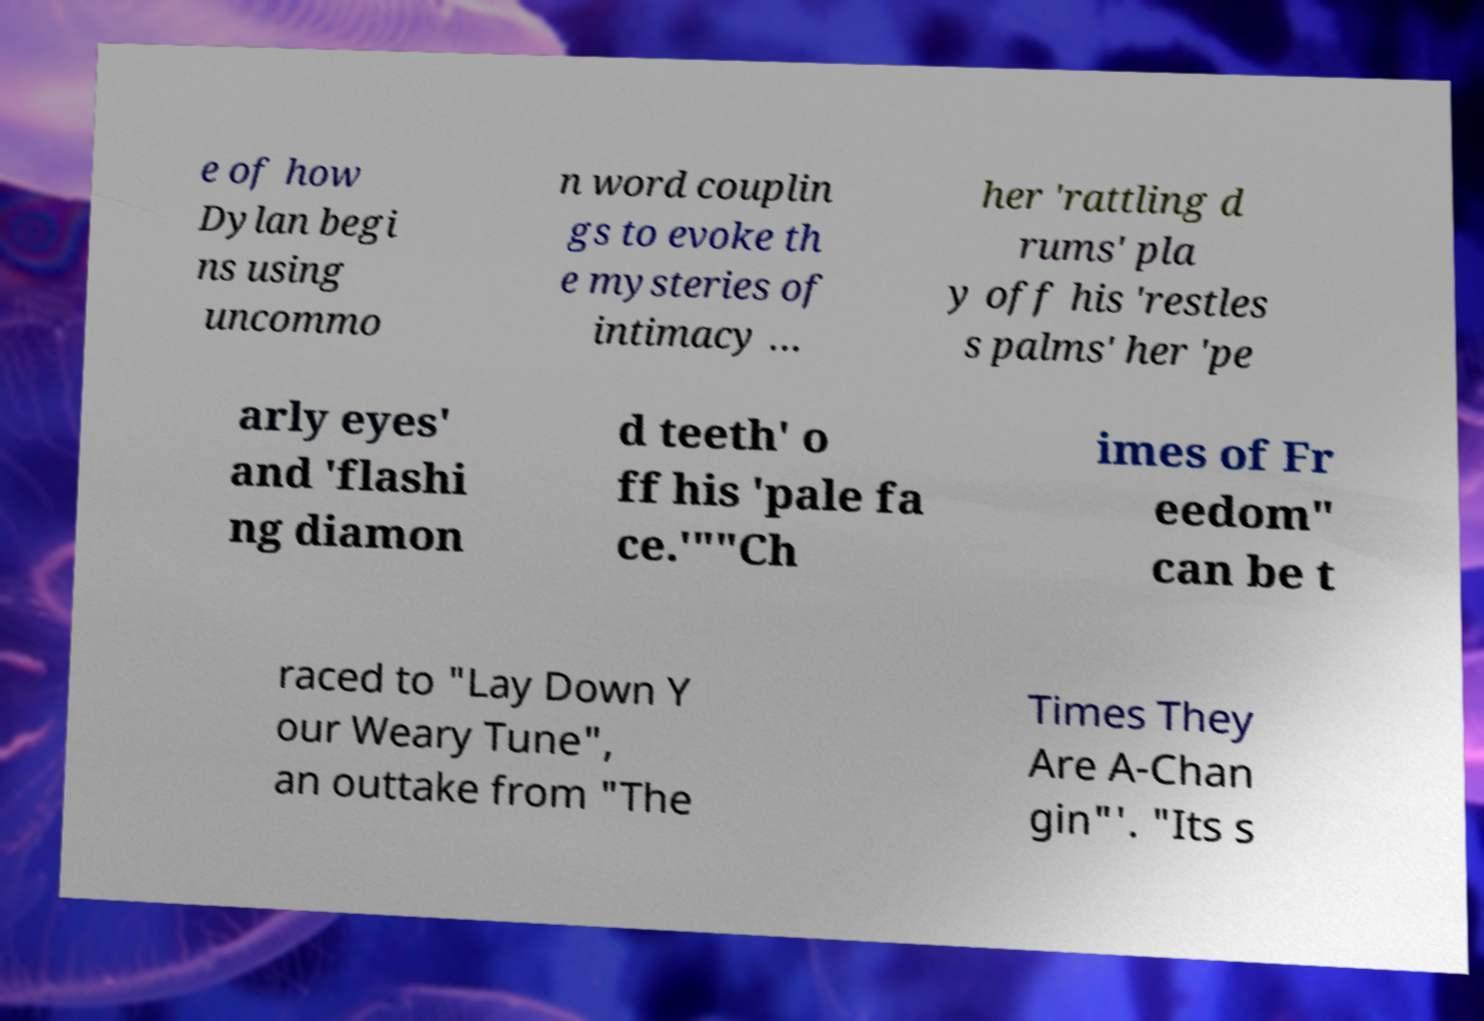There's text embedded in this image that I need extracted. Can you transcribe it verbatim? e of how Dylan begi ns using uncommo n word couplin gs to evoke th e mysteries of intimacy … her 'rattling d rums' pla y off his 'restles s palms' her 'pe arly eyes' and 'flashi ng diamon d teeth' o ff his 'pale fa ce.'""Ch imes of Fr eedom" can be t raced to "Lay Down Y our Weary Tune", an outtake from "The Times They Are A-Chan gin"'. "Its s 